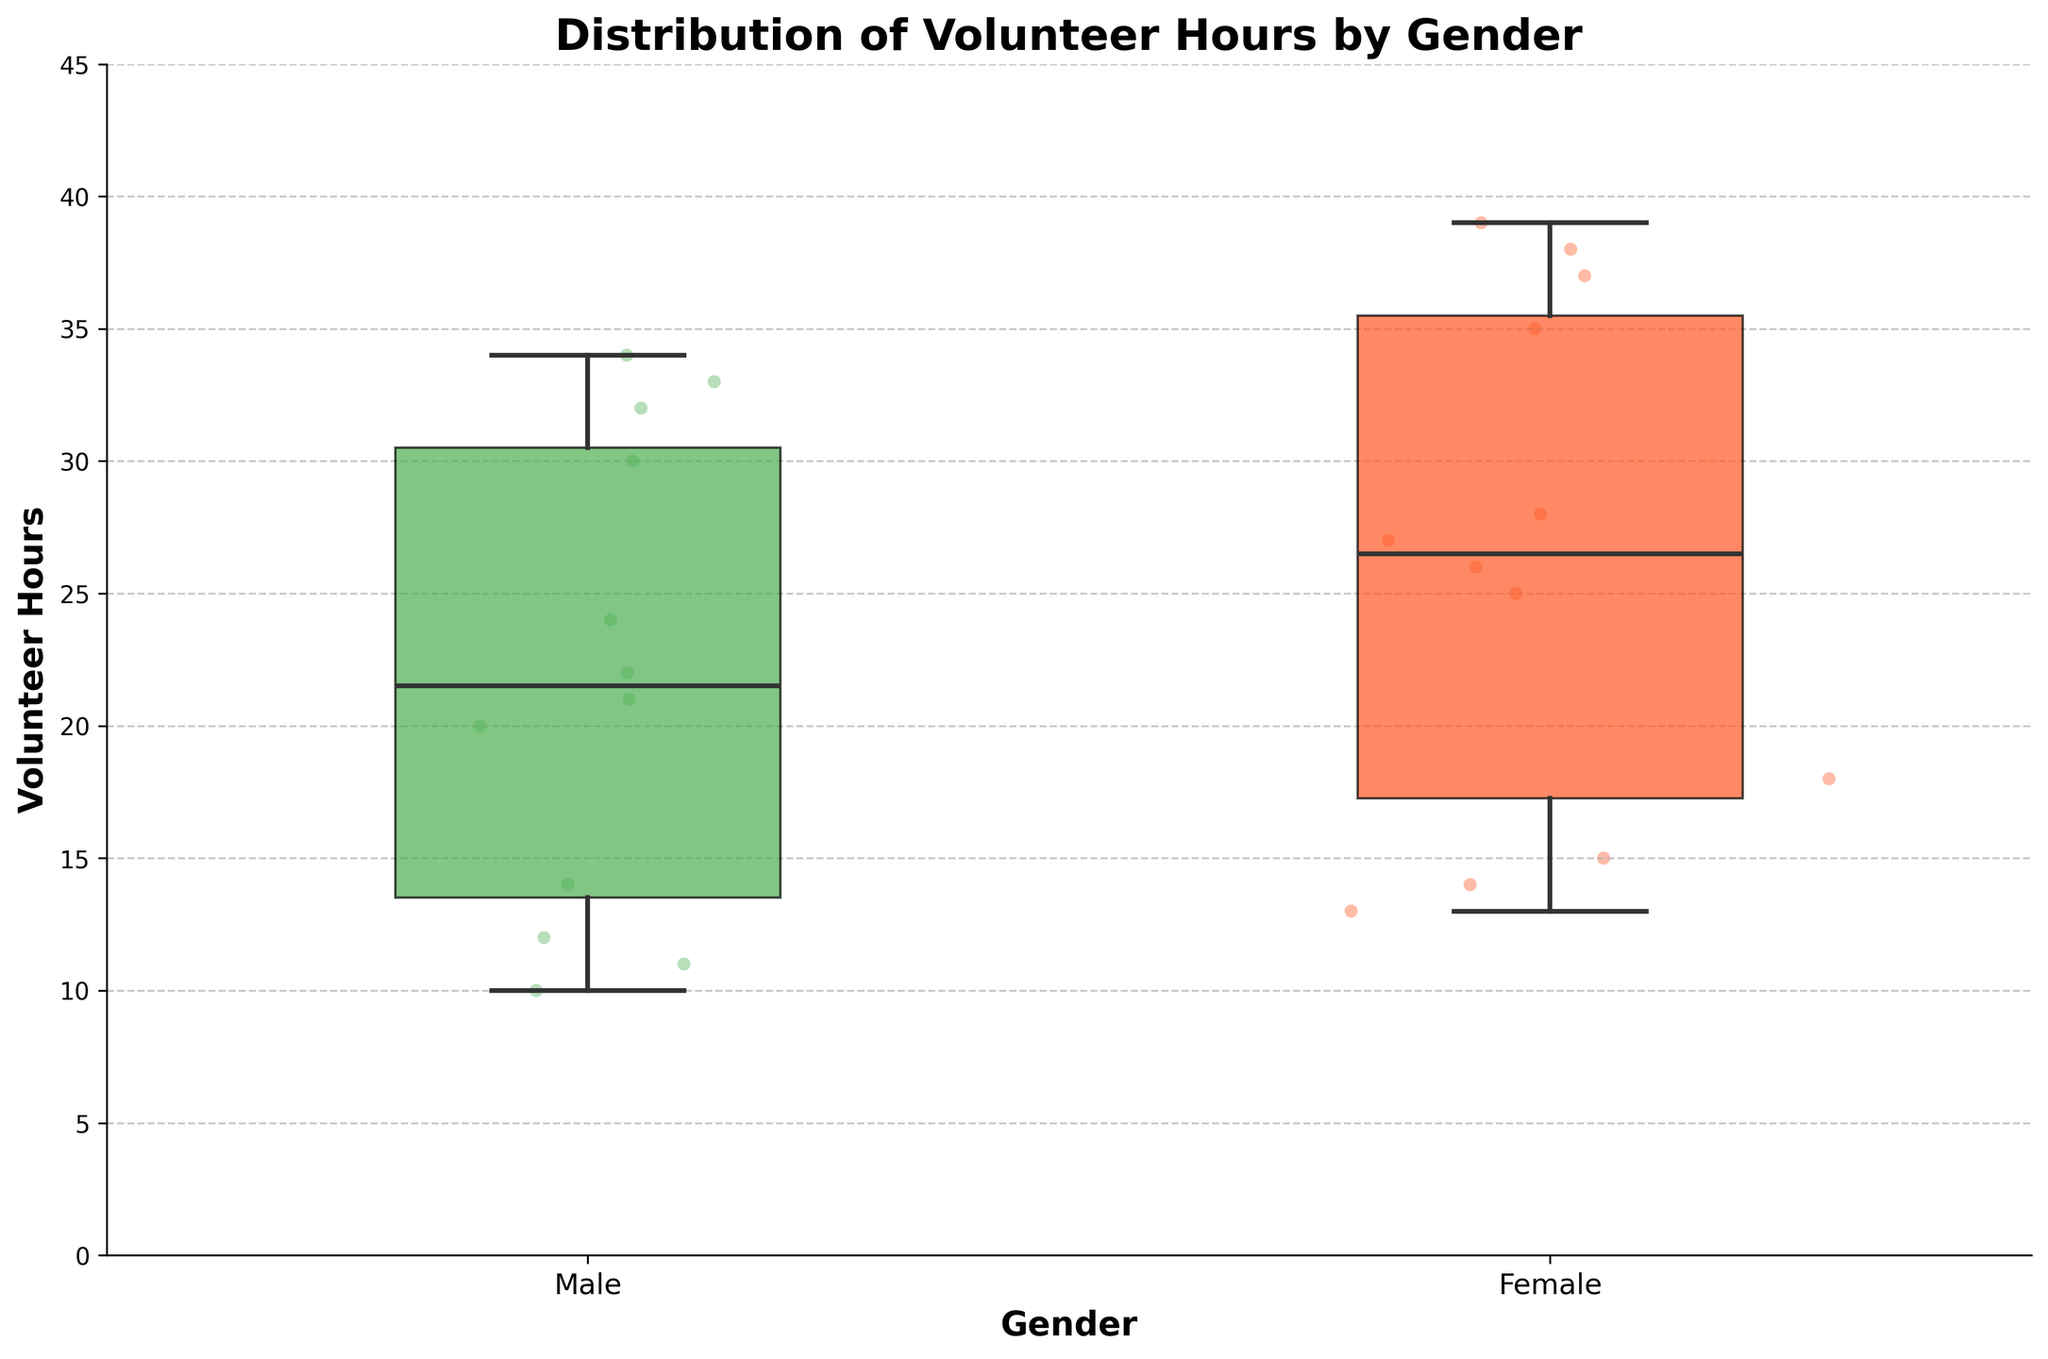What is the title of the plot? The title is usually displayed at the top of the plot. Here, it reads "Distribution of Volunteer Hours by Gender".
Answer: Distribution of Volunteer Hours by Gender What are the labels of the x-axis and y-axis? The x-axis and y-axis labels help identify what each axis represents. The x-axis is labeled "Gender", and the y-axis is labeled "Volunteer Hours".
Answer: Gender and Volunteer Hours Which gender has a wider spread of volunteer hours? To see which gender has a wider spread, observe the range from the lower to the upper whiskers in each box plot. The male group has a wider spread than the female group.
Answer: Male What are the colors of the boxes for male and female groups, respectively? The colors help differentiate between the groups. The male group's box is green, and the female group's box is red.
Answer: Green and Red What is the median volunteer hours for the female group? The median is the line inside the box of the female group. Observing the box plot, it is around 27 hours.
Answer: 27 hours What is the range of volunteer hours for the male group? The range is the difference between the maximum and minimum values represented by the whiskers. The male group ranges from around 10 to 34 hours.
Answer: 24 hours How do the median values compare between male and female groups? Compare the central lines in each box. The female group's median (27 hours) is higher than the male group's median (23 hours).
Answer: Female is higher Which socio-economic status category appears to have the highest median volunteer hours for both genders? By spotting the median lines within each box, identify the highest medians for each gender. High socio-economic status appears to have the highest medians for both groups.
Answer: High Do any male students have more volunteer hours than the female students? Reviewing the scatter points, there are some male students with volunteer hours closer to the upper whisker of the female group, indicating some overlap.
Answer: Yes 